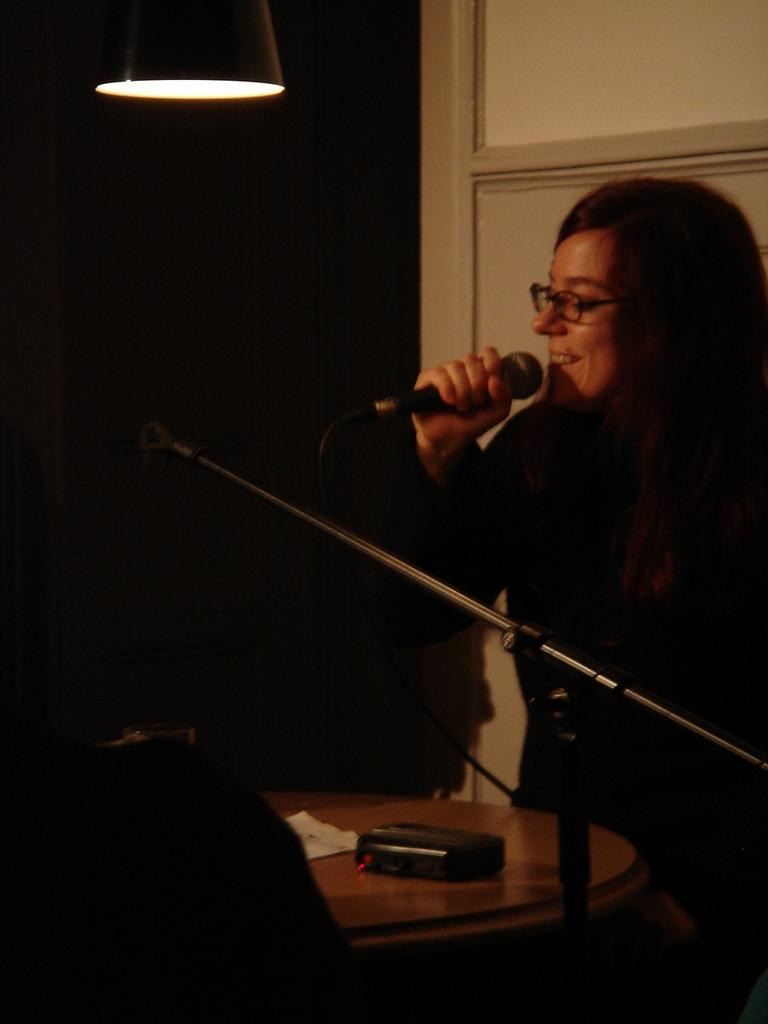Who is present in the image? There is a woman in the image. What is the woman wearing? The woman is wearing specs. What is the woman holding in the image? The woman is holding a mic. What is in front of the woman? There is a mic stand in front of the woman. What piece of furniture can be seen in the image? There is a table in the image. What is on the table? There is an object on the table. What can be seen providing illumination in the image? There is a light in the image. What type of railway can be seen in the image? There is no railway present in the image. Is the woman in the image standing in a bedroom? The image does not provide any information about the location or setting, so it cannot be determined if it is a bedroom or not. 